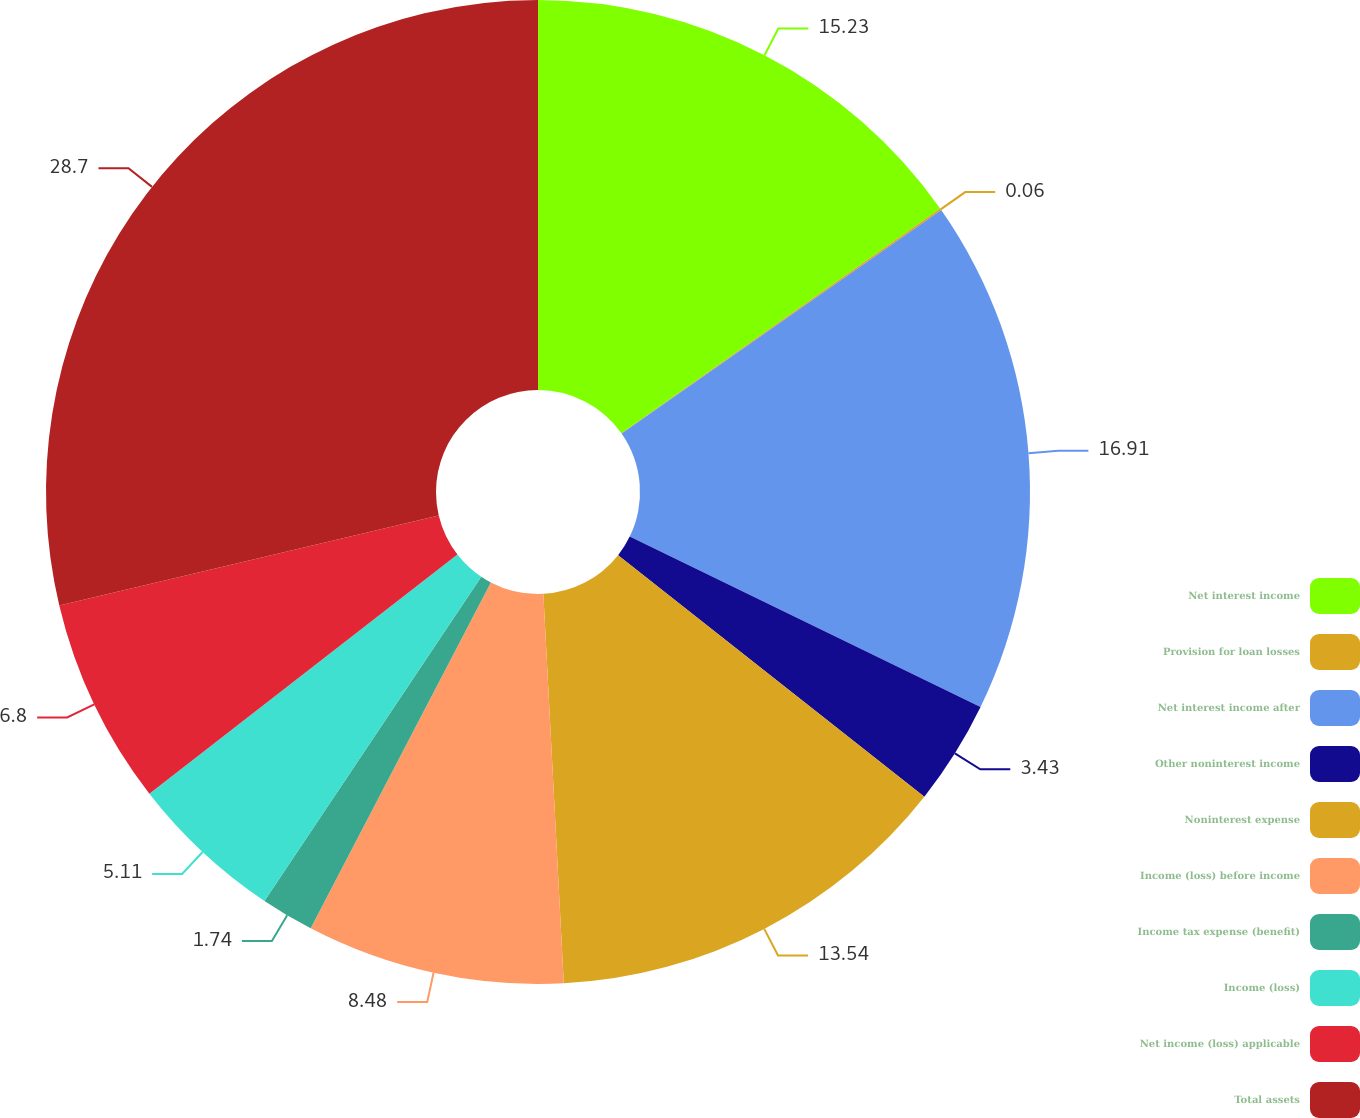Convert chart to OTSL. <chart><loc_0><loc_0><loc_500><loc_500><pie_chart><fcel>Net interest income<fcel>Provision for loan losses<fcel>Net interest income after<fcel>Other noninterest income<fcel>Noninterest expense<fcel>Income (loss) before income<fcel>Income tax expense (benefit)<fcel>Income (loss)<fcel>Net income (loss) applicable<fcel>Total assets<nl><fcel>15.23%<fcel>0.06%<fcel>16.91%<fcel>3.43%<fcel>13.54%<fcel>8.48%<fcel>1.74%<fcel>5.11%<fcel>6.8%<fcel>28.71%<nl></chart> 